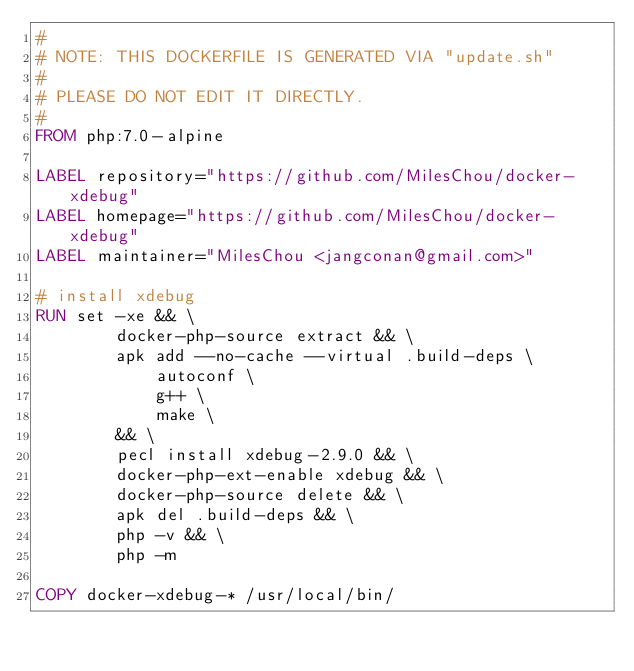<code> <loc_0><loc_0><loc_500><loc_500><_Dockerfile_>#
# NOTE: THIS DOCKERFILE IS GENERATED VIA "update.sh"
#
# PLEASE DO NOT EDIT IT DIRECTLY.
#
FROM php:7.0-alpine

LABEL repository="https://github.com/MilesChou/docker-xdebug"
LABEL homepage="https://github.com/MilesChou/docker-xdebug"
LABEL maintainer="MilesChou <jangconan@gmail.com>"

# install xdebug
RUN set -xe && \
        docker-php-source extract && \
        apk add --no-cache --virtual .build-deps \
            autoconf \
            g++ \
            make \
        && \
        pecl install xdebug-2.9.0 && \
        docker-php-ext-enable xdebug && \
        docker-php-source delete && \
        apk del .build-deps && \
        php -v && \
        php -m

COPY docker-xdebug-* /usr/local/bin/
</code> 